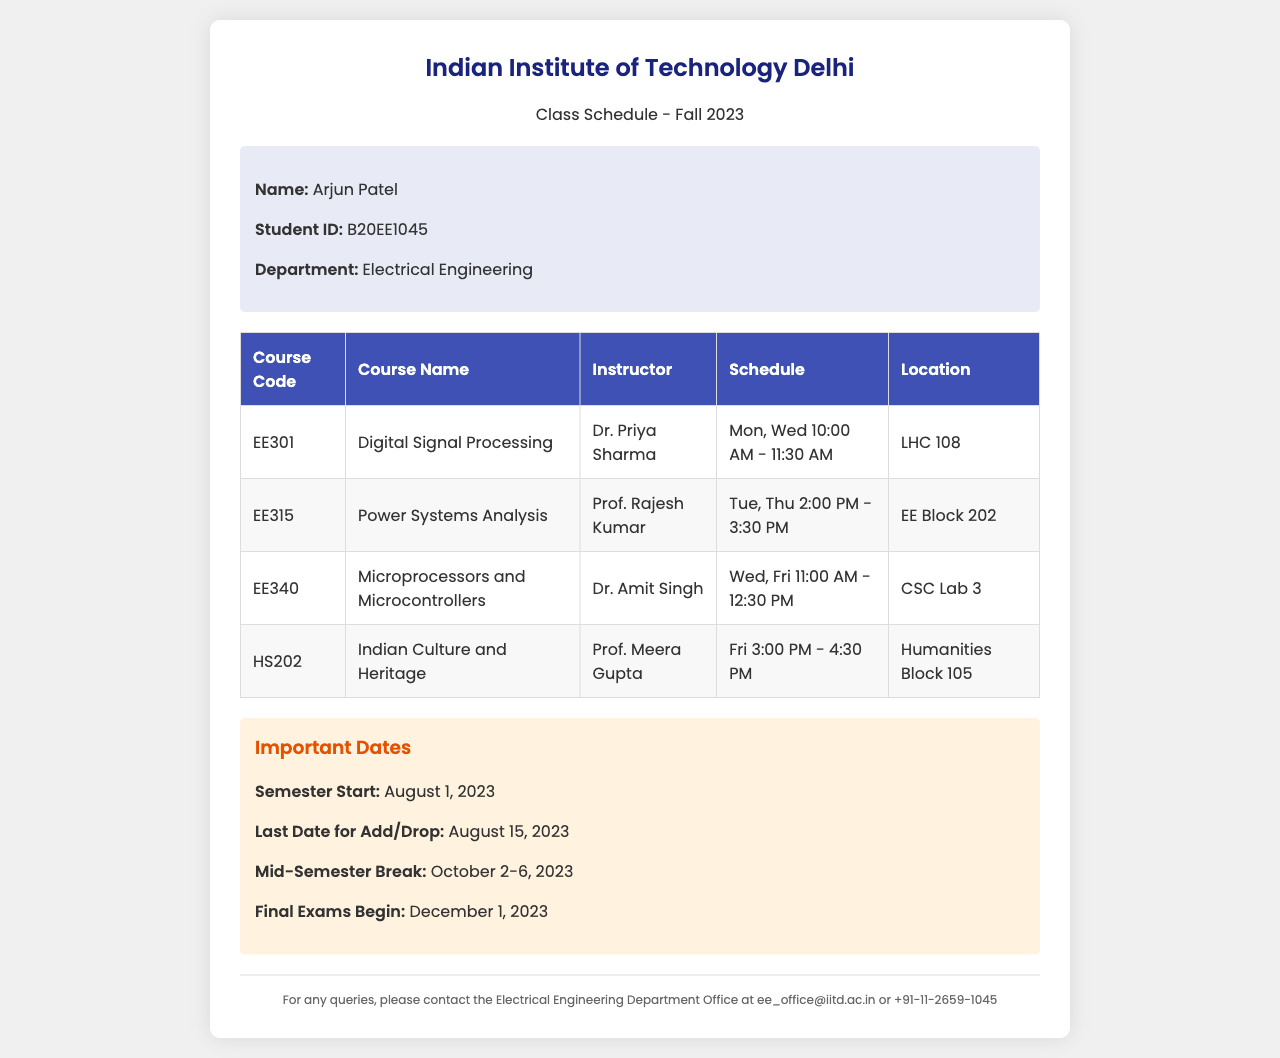What is the student's name? The document contains student information stating the student's name at the top of the section.
Answer: Arjun Patel What is the course code for Digital Signal Processing? The document includes a table listing the courses, and the code for Digital Signal Processing is specified there.
Answer: EE301 Who teaches Power Systems Analysis? The instructor's name for Power Systems Analysis is provided in the course table of the document.
Answer: Prof. Rajesh Kumar When does the semester start? The document outlines important dates, including the semester start date.
Answer: August 1, 2023 What is the location for the Indian Culture and Heritage class? The course table lists course details, including the location of Indian Culture and Heritage.
Answer: Humanities Block 105 What is the schedule for Microprocessors and Microcontrollers? The document provides a schedule section for each course in the course table.
Answer: Wed, Fri 11:00 AM - 12:30 PM How many courses are listed in the document? The course table details the number of courses along with their codes and titles, allowing for a count of the entries.
Answer: 4 When is the last date for add/drop? Important dates are listed in the document, specifying the last date for add/drop.
Answer: August 15, 2023 What type of document is this? The title and structure indicate the nature of the document, specifically intended for student information.
Answer: Class Schedule Fax 